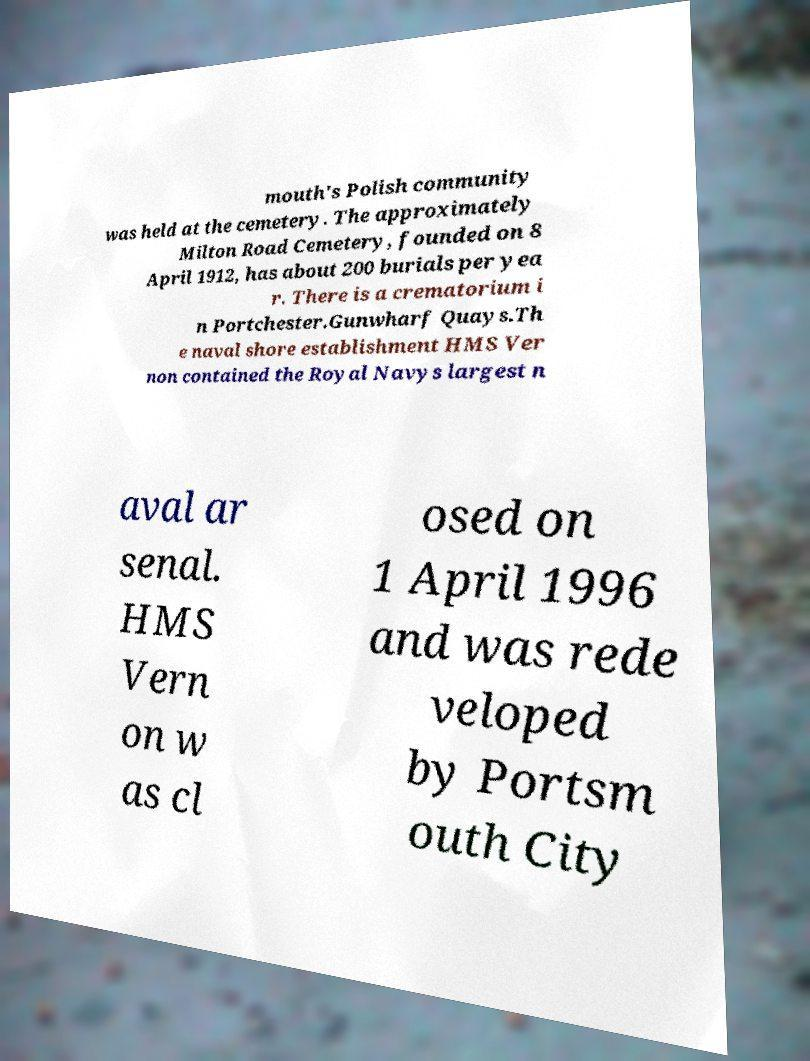There's text embedded in this image that I need extracted. Can you transcribe it verbatim? mouth's Polish community was held at the cemetery. The approximately Milton Road Cemetery, founded on 8 April 1912, has about 200 burials per yea r. There is a crematorium i n Portchester.Gunwharf Quays.Th e naval shore establishment HMS Ver non contained the Royal Navys largest n aval ar senal. HMS Vern on w as cl osed on 1 April 1996 and was rede veloped by Portsm outh City 